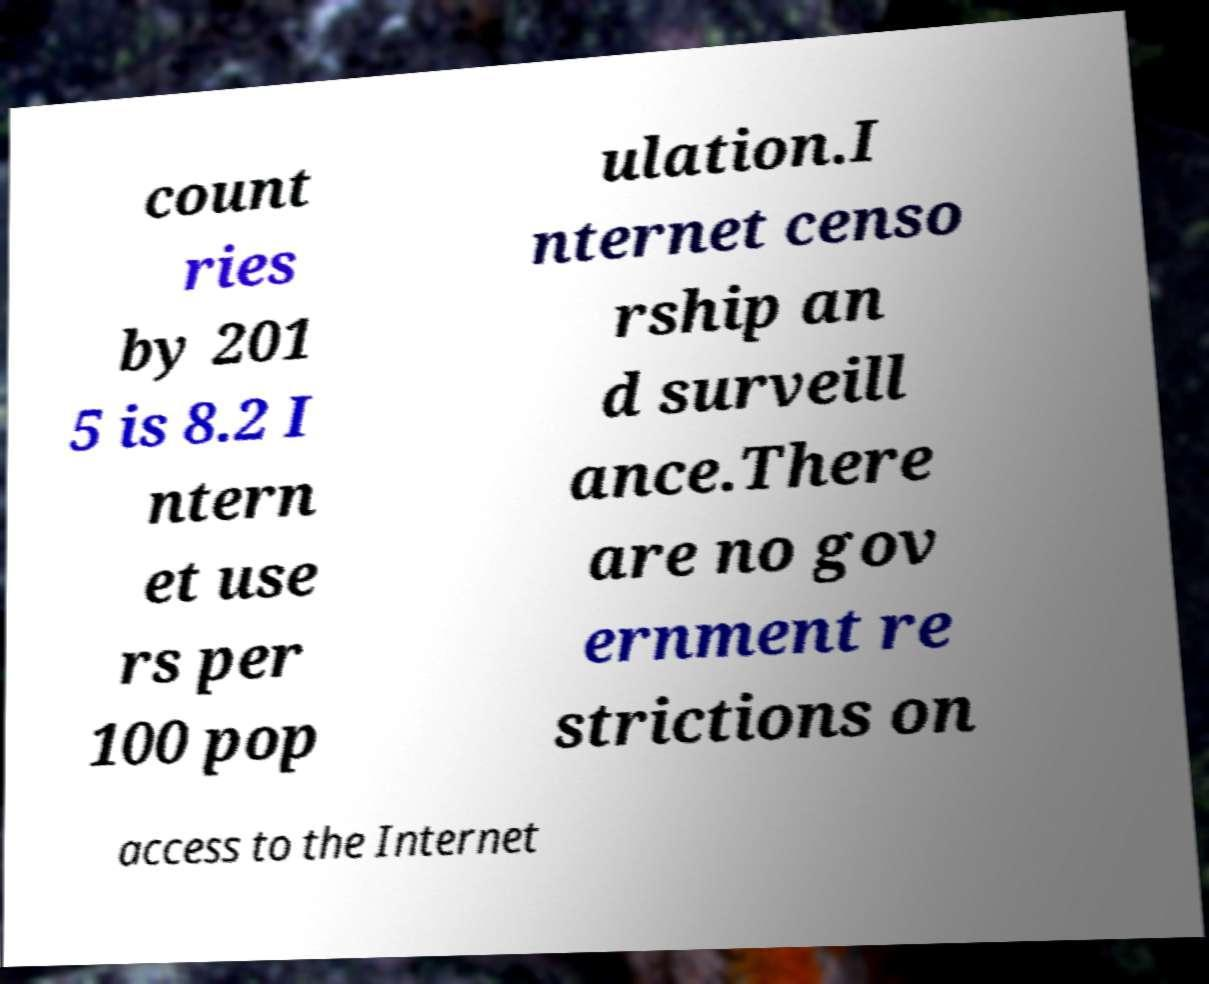I need the written content from this picture converted into text. Can you do that? count ries by 201 5 is 8.2 I ntern et use rs per 100 pop ulation.I nternet censo rship an d surveill ance.There are no gov ernment re strictions on access to the Internet 